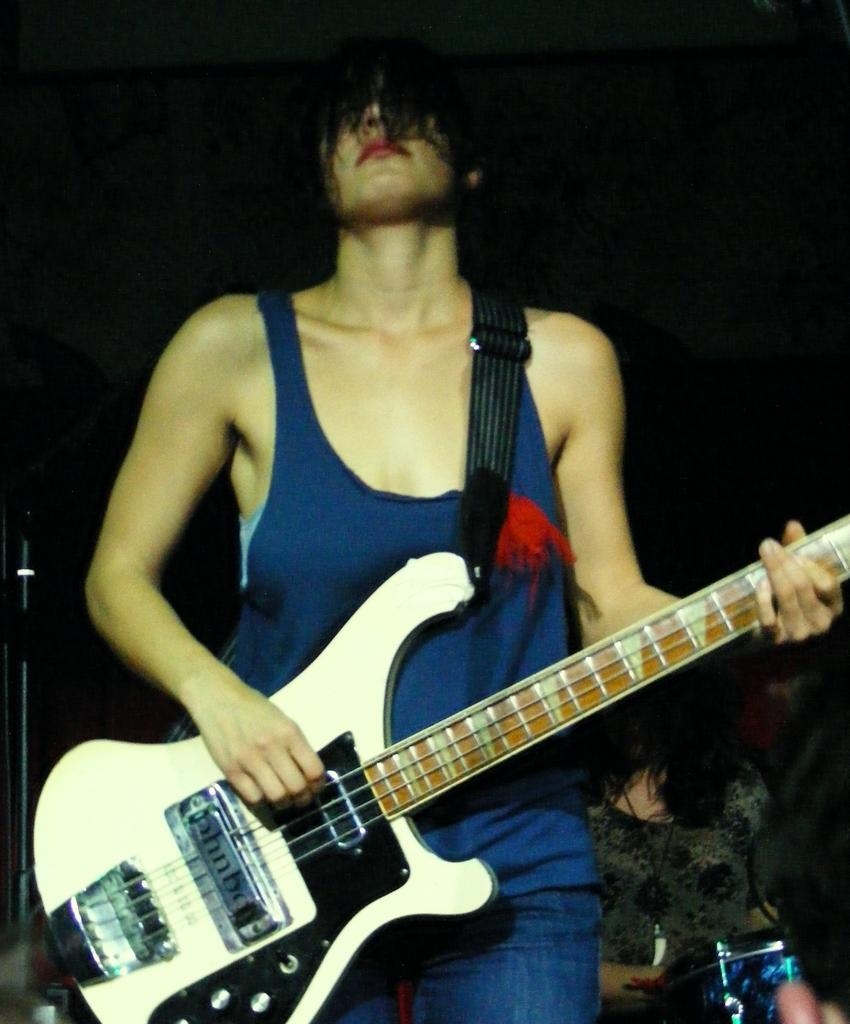What is the lady in the blue top doing in the image? The lady with the blue top is playing a guitar in the image. What is the lady with the blue top's posture in the image? The lady with the blue top is standing in the image. Can you describe the other lady in the image? The other lady is sitting in the image. What type of twig is the lady with the blue top using as a guitar pick in the image? There is no twig visible in the image, and the lady with the blue top is not using a twig as a guitar pick. 